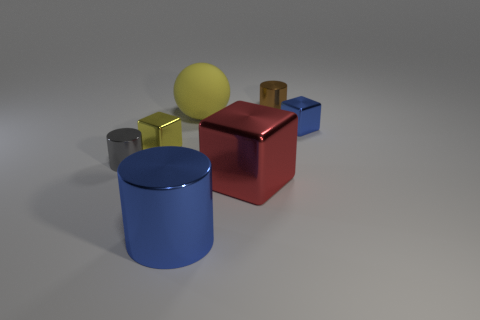There is another object that is the same color as the rubber object; what is its material?
Offer a terse response. Metal. There is a rubber object; does it have the same color as the small shiny cylinder on the right side of the gray object?
Your answer should be compact. No. What color is the big shiny cylinder?
Your answer should be very brief. Blue. How many objects are either large yellow things or gray shiny cylinders?
Keep it short and to the point. 2. What material is the yellow object that is the same size as the brown shiny cylinder?
Your answer should be very brief. Metal. How big is the blue object that is behind the large blue shiny cylinder?
Provide a succinct answer. Small. What is the blue cylinder made of?
Your answer should be very brief. Metal. How many objects are either small shiny cylinders that are to the left of the matte thing or tiny things in front of the yellow shiny cube?
Give a very brief answer. 1. How many other things are the same color as the ball?
Your response must be concise. 1. Do the tiny gray object and the yellow thing that is behind the yellow block have the same shape?
Provide a short and direct response. No. 